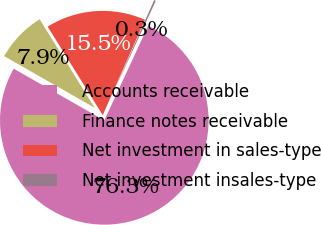Convert chart to OTSL. <chart><loc_0><loc_0><loc_500><loc_500><pie_chart><fcel>Accounts receivable<fcel>Finance notes receivable<fcel>Net investment in sales-type<fcel>Net investment insales-type<nl><fcel>76.33%<fcel>7.89%<fcel>15.49%<fcel>0.28%<nl></chart> 